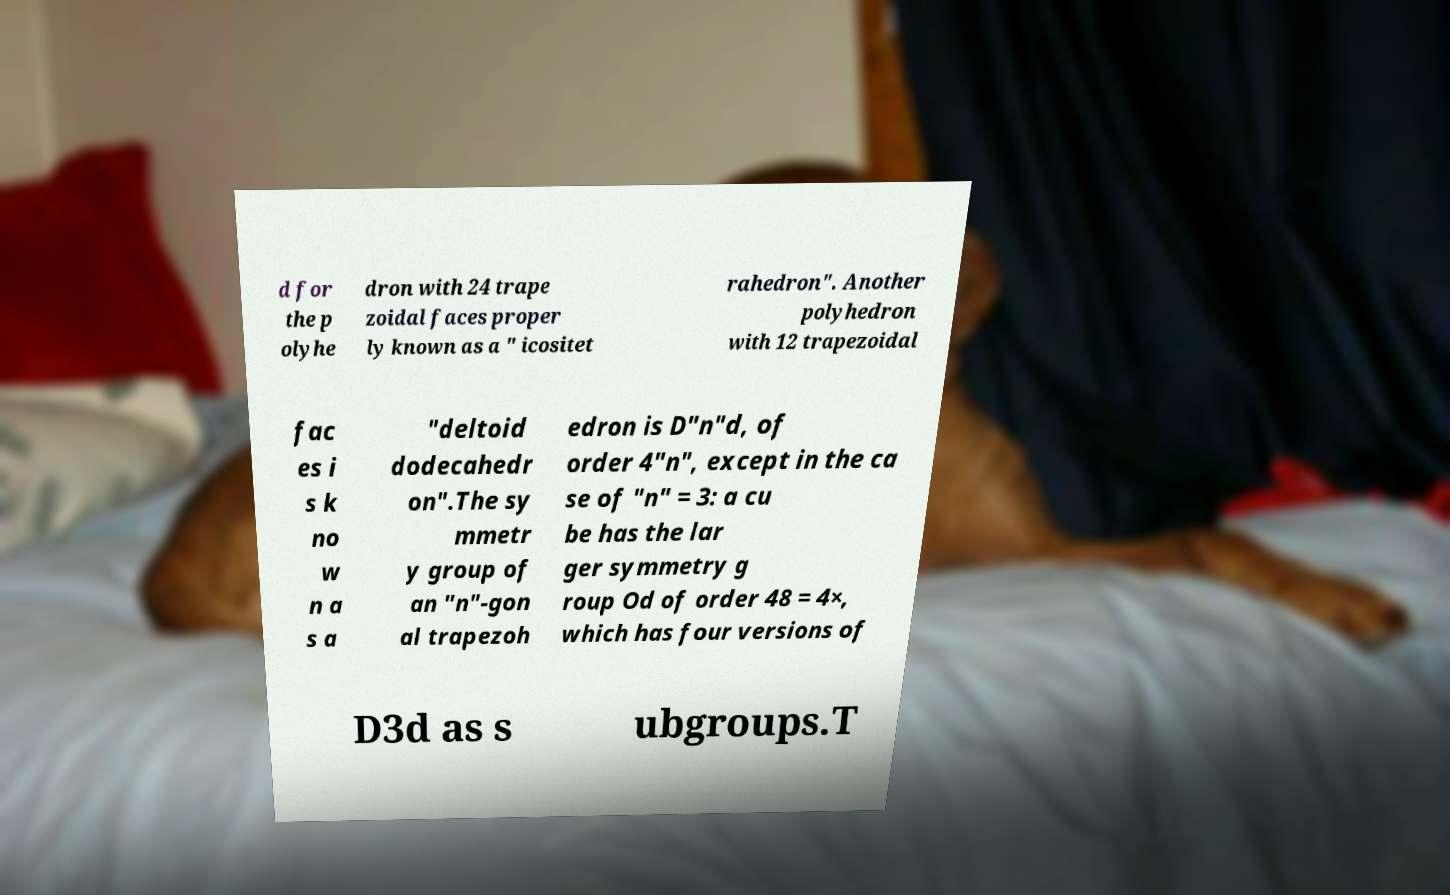Could you assist in decoding the text presented in this image and type it out clearly? d for the p olyhe dron with 24 trape zoidal faces proper ly known as a " icositet rahedron". Another polyhedron with 12 trapezoidal fac es i s k no w n a s a "deltoid dodecahedr on".The sy mmetr y group of an "n"-gon al trapezoh edron is D"n"d, of order 4"n", except in the ca se of "n" = 3: a cu be has the lar ger symmetry g roup Od of order 48 = 4×, which has four versions of D3d as s ubgroups.T 